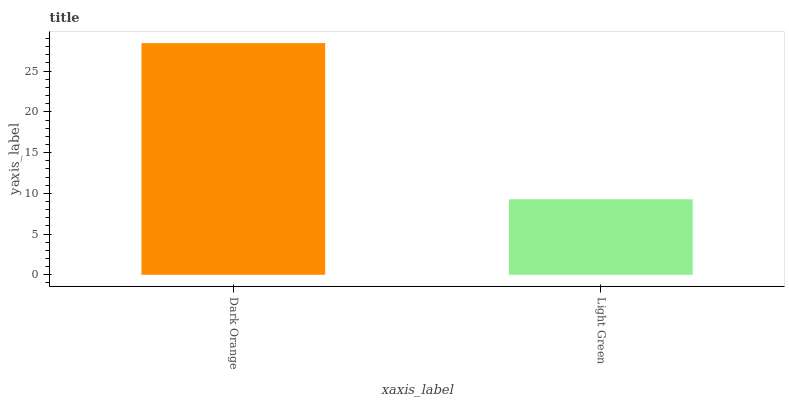Is Light Green the maximum?
Answer yes or no. No. Is Dark Orange greater than Light Green?
Answer yes or no. Yes. Is Light Green less than Dark Orange?
Answer yes or no. Yes. Is Light Green greater than Dark Orange?
Answer yes or no. No. Is Dark Orange less than Light Green?
Answer yes or no. No. Is Dark Orange the high median?
Answer yes or no. Yes. Is Light Green the low median?
Answer yes or no. Yes. Is Light Green the high median?
Answer yes or no. No. Is Dark Orange the low median?
Answer yes or no. No. 